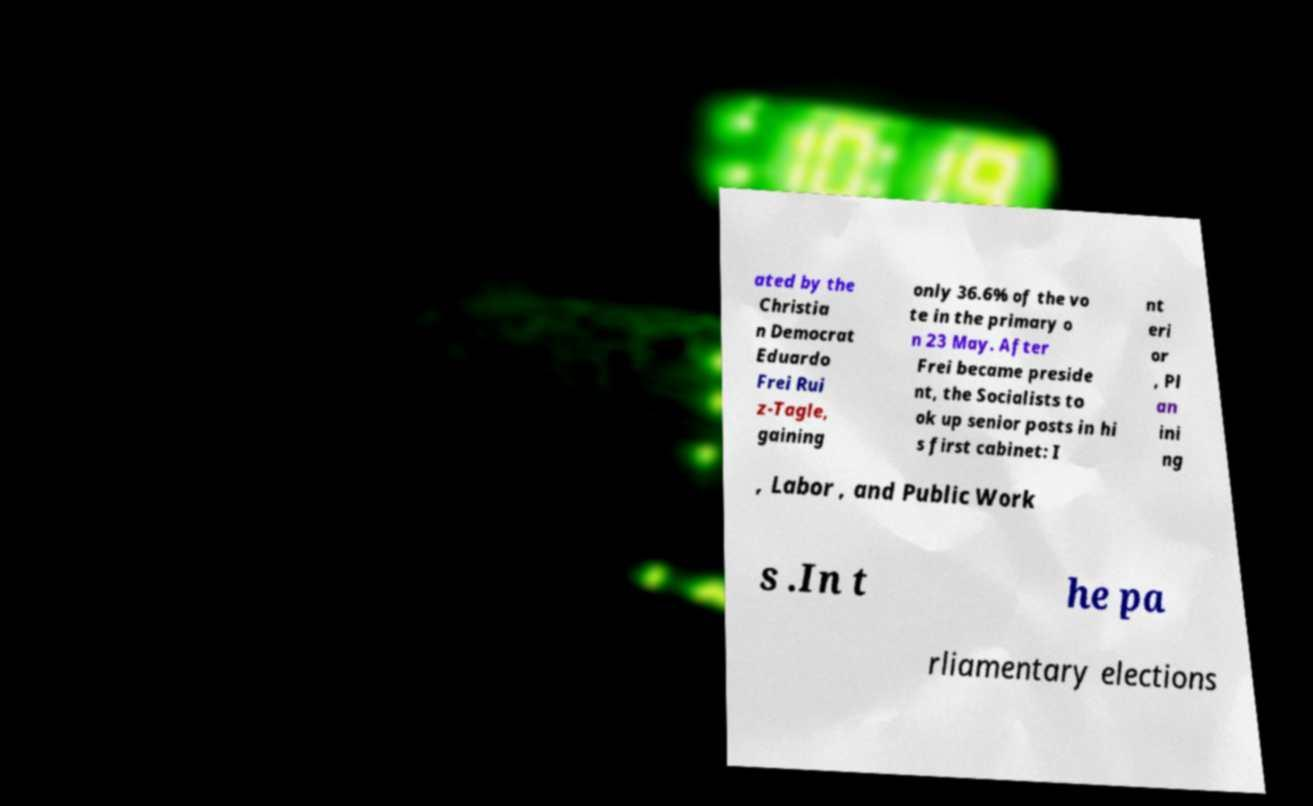Please read and relay the text visible in this image. What does it say? ated by the Christia n Democrat Eduardo Frei Rui z-Tagle, gaining only 36.6% of the vo te in the primary o n 23 May. After Frei became preside nt, the Socialists to ok up senior posts in hi s first cabinet: I nt eri or , Pl an ini ng , Labor , and Public Work s .In t he pa rliamentary elections 